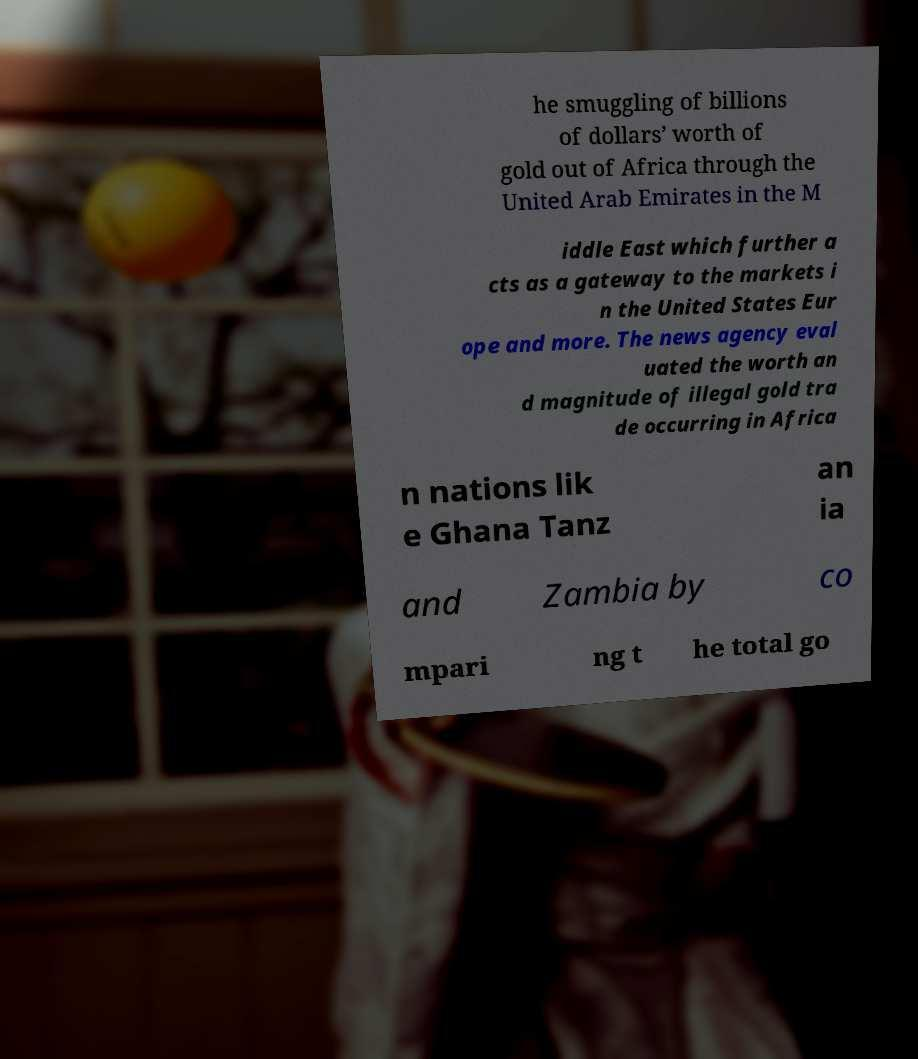Please identify and transcribe the text found in this image. he smuggling of billions of dollars’ worth of gold out of Africa through the United Arab Emirates in the M iddle East which further a cts as a gateway to the markets i n the United States Eur ope and more. The news agency eval uated the worth an d magnitude of illegal gold tra de occurring in Africa n nations lik e Ghana Tanz an ia and Zambia by co mpari ng t he total go 